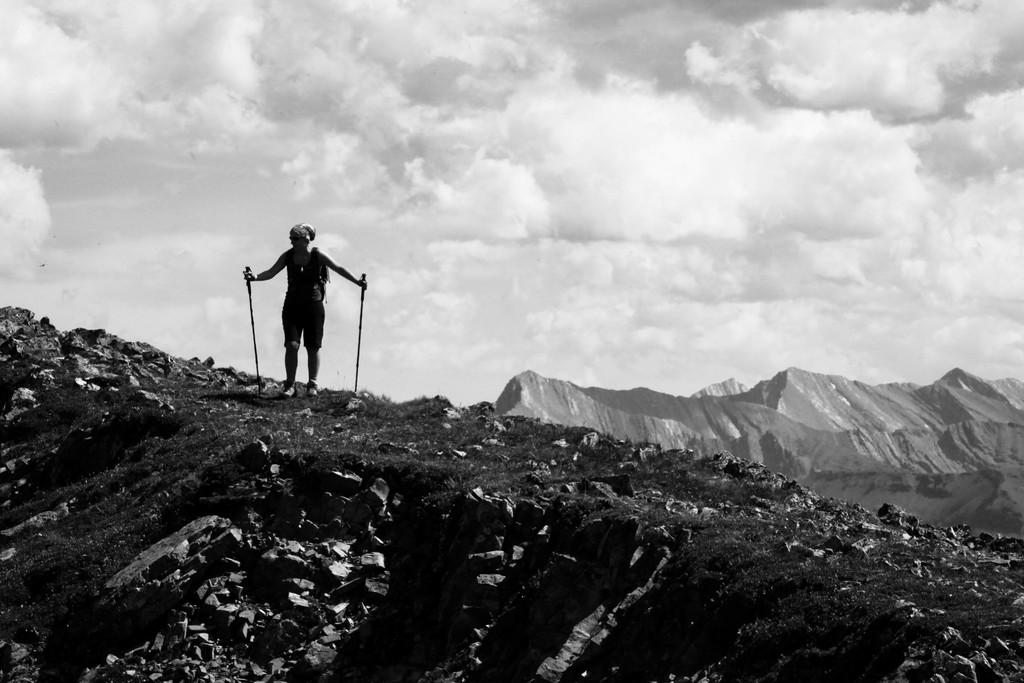What is the main subject of the image? There is a person standing in the middle of the image. What is the person holding in the image? The person is holding sticks. What can be seen in the background of the image? There are hills and clouds in the background of the image. What is the color scheme of the image? The image is in black and white. What type of growth can be seen on the dinosaurs in the image? There are no dinosaurs present in the image, so there is no growth to observe. 